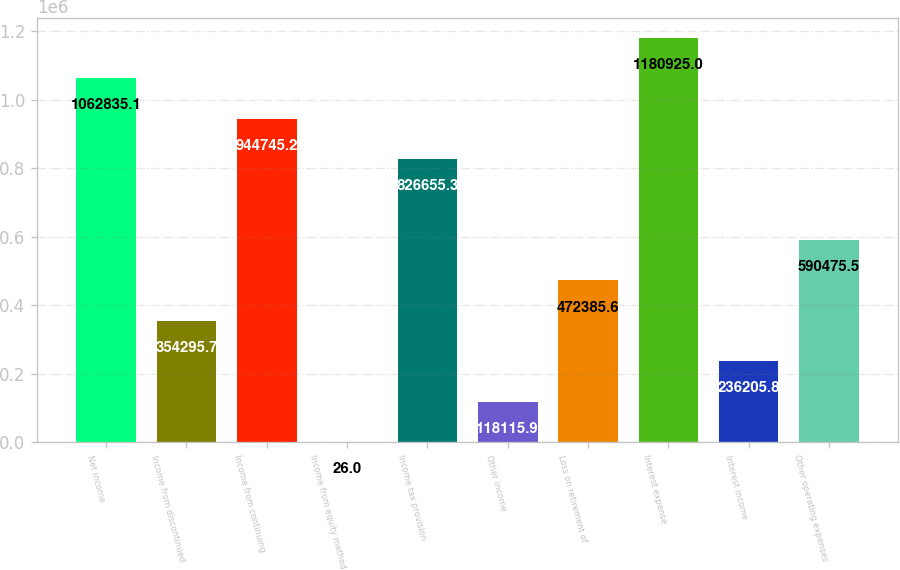<chart> <loc_0><loc_0><loc_500><loc_500><bar_chart><fcel>Net income<fcel>Income from discontinued<fcel>Income from continuing<fcel>Income from equity method<fcel>Income tax provision<fcel>Other income<fcel>Loss on retirement of<fcel>Interest expense<fcel>Interest income<fcel>Other operating expenses<nl><fcel>1.06284e+06<fcel>354296<fcel>944745<fcel>26<fcel>826655<fcel>118116<fcel>472386<fcel>1.18092e+06<fcel>236206<fcel>590476<nl></chart> 